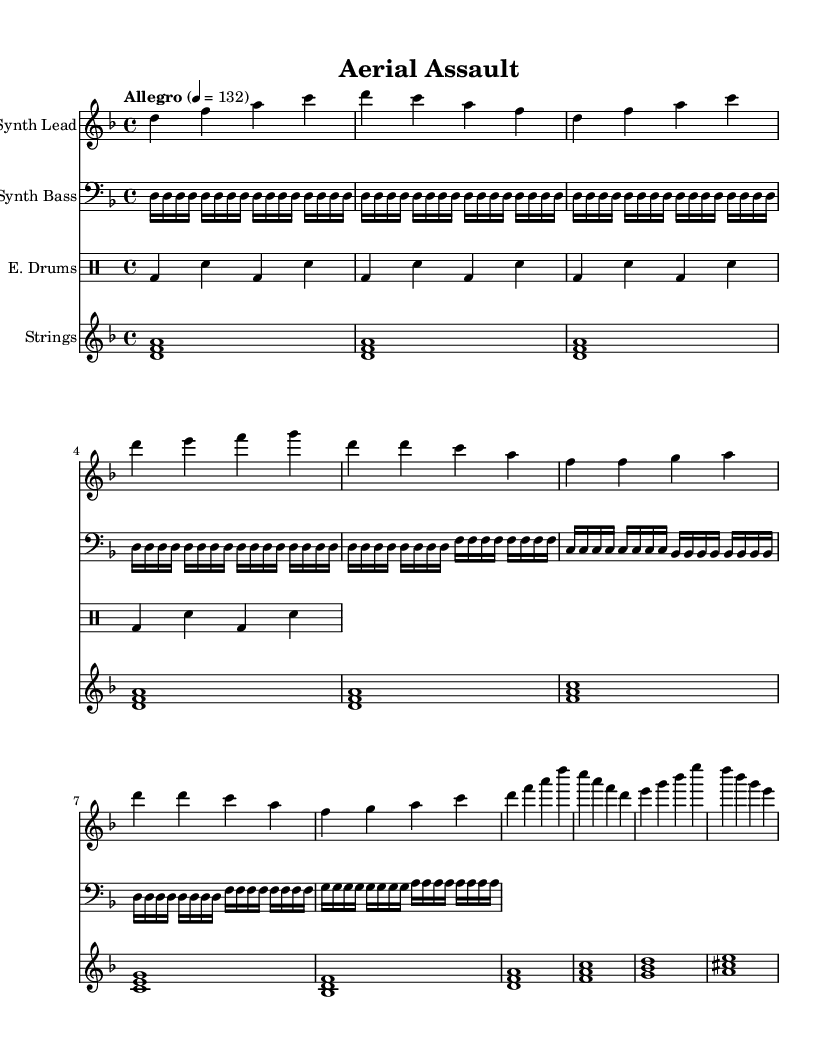What is the key signature of this music? The key signature is indicated in the global context of the music, where it is specified as D minor. This can be inferred from the declaration `\key d \minor`.
Answer: D minor What is the time signature of this piece? The time signature is found in the same global context, alongside the key signature. Here, the declaration `\time 4/4` indicates that the time signature is 4/4, meaning there are four beats per measure.
Answer: 4/4 What is the tempo marking of this music? The tempo is indicated as "Allegro" and is written with the tempo designation in the global section where it states `\tempo "Allegro" 4 = 132`. This implies the music should be played at a fast pace.
Answer: Allegro How many sections are there in the structure of the piece? By analyzing the provided musical parts, we can divide the arrangement into three distinct sections: the Intro, Verse, and Chorus. Each section consists of musical phrases that follow this structure, reinforcing the term "sections."
Answer: Three What instrument plays the lead part in the music? The lead part of the music is specified in the `\set Staff.instrumentName` for the synth lead, which denotes the instrument responsible for the melodic line in the piece. The term 'Synth Lead' is directly given in the notational context of the piece.
Answer: Synth Lead Which instrument section provides the rhythmic foundation of the music? The rhythmic foundation is established by the E. Drums section as seen in the `\drummode` context where it indicates a drum pattern consisting of bass and snare notes, a common way to maintain rhythmic consistency in electronic soundtracks.
Answer: E. Drums What are the names of the instruments used in this score? The instruments are specifically labeled in their corresponding sections using `\set Staff.instrumentName`. The names provided are Synth Lead, Synth Bass, E. Drums, and Strings. This is a direct interpretation of the instrumental context specified in the code.
Answer: Synth Lead, Synth Bass, E. Drums, Strings 